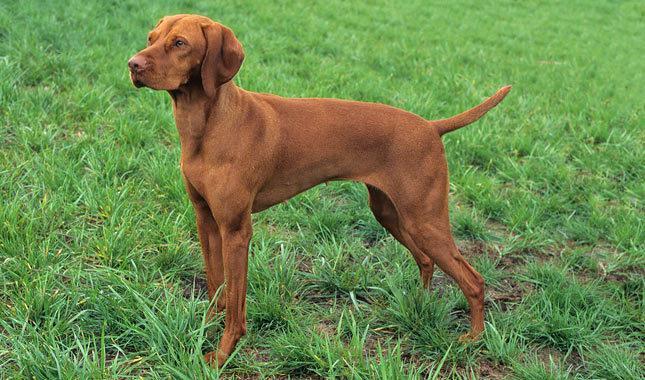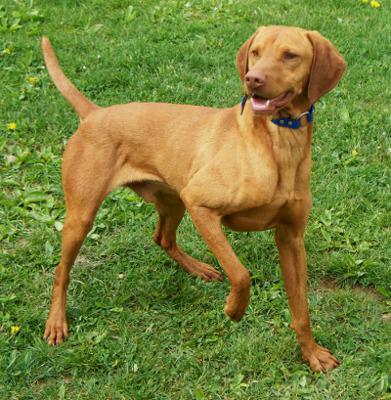The first image is the image on the left, the second image is the image on the right. For the images displayed, is the sentence "The dog in the image on the right is on a leash." factually correct? Answer yes or no. No. The first image is the image on the left, the second image is the image on the right. Analyze the images presented: Is the assertion "One image shows a dog standing in profile with its body turned leftward, and the other image shows a dog standing with its body turned rightward and with one front paw raised." valid? Answer yes or no. Yes. 